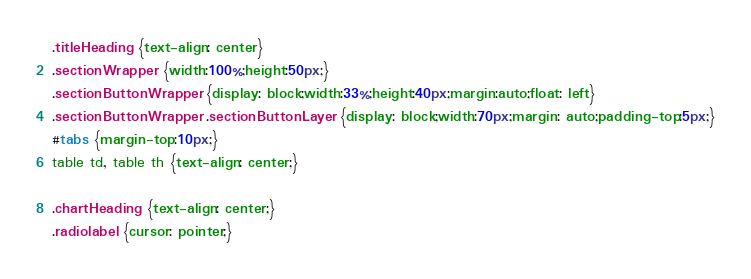Convert code to text. <code><loc_0><loc_0><loc_500><loc_500><_CSS_>.titleHeading {text-align: center}
.sectionWrapper {width:100%;height:50px;}
.sectionButtonWrapper {display: block;width:33%;height:40px;margin:auto;float: left}
.sectionButtonWrapper .sectionButtonLayer {display: block;width:70px;margin: auto;padding-top:5px;}
#tabs {margin-top:10px;}
table td, table th {text-align: center;}

.chartHeading {text-align: center;}
.radiolabel {cursor: pointer;}</code> 